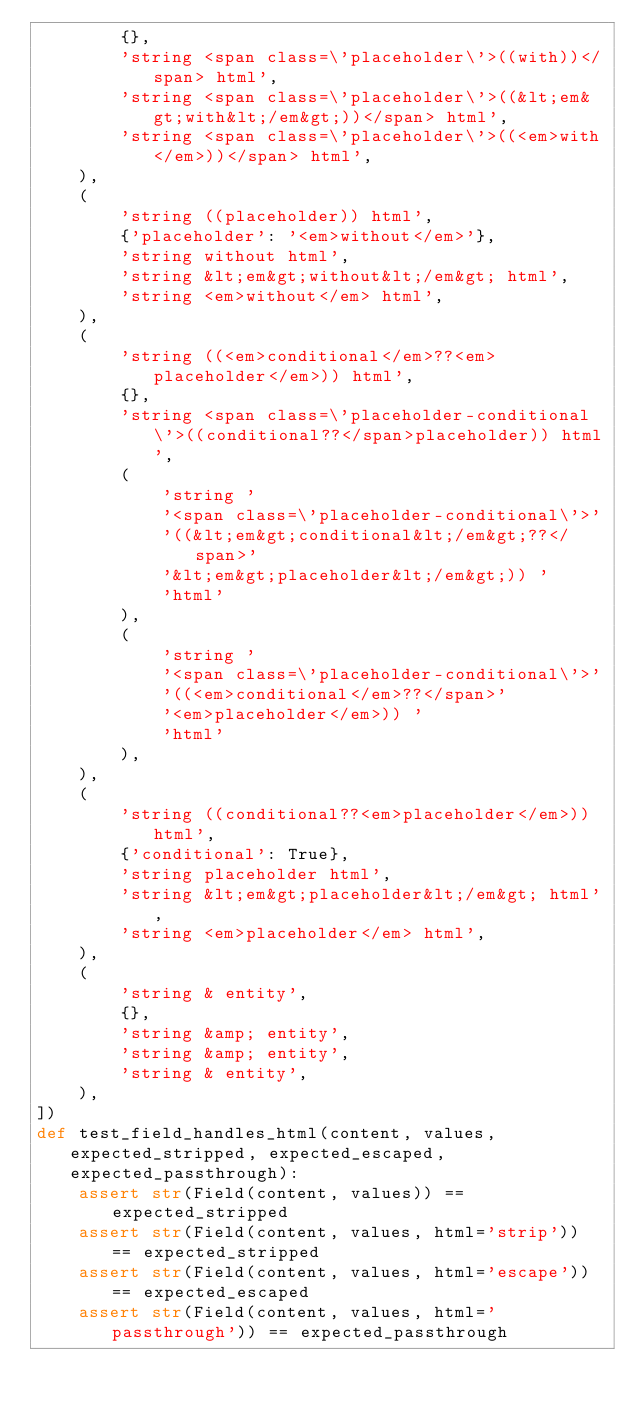Convert code to text. <code><loc_0><loc_0><loc_500><loc_500><_Python_>        {},
        'string <span class=\'placeholder\'>((with))</span> html',
        'string <span class=\'placeholder\'>((&lt;em&gt;with&lt;/em&gt;))</span> html',
        'string <span class=\'placeholder\'>((<em>with</em>))</span> html',
    ),
    (
        'string ((placeholder)) html',
        {'placeholder': '<em>without</em>'},
        'string without html',
        'string &lt;em&gt;without&lt;/em&gt; html',
        'string <em>without</em> html',
    ),
    (
        'string ((<em>conditional</em>??<em>placeholder</em>)) html',
        {},
        'string <span class=\'placeholder-conditional\'>((conditional??</span>placeholder)) html',
        (
            'string '
            '<span class=\'placeholder-conditional\'>'
            '((&lt;em&gt;conditional&lt;/em&gt;??</span>'
            '&lt;em&gt;placeholder&lt;/em&gt;)) '
            'html'
        ),
        (
            'string '
            '<span class=\'placeholder-conditional\'>'
            '((<em>conditional</em>??</span>'
            '<em>placeholder</em>)) '
            'html'
        ),
    ),
    (
        'string ((conditional??<em>placeholder</em>)) html',
        {'conditional': True},
        'string placeholder html',
        'string &lt;em&gt;placeholder&lt;/em&gt; html',
        'string <em>placeholder</em> html',
    ),
    (
        'string & entity',
        {},
        'string &amp; entity',
        'string &amp; entity',
        'string & entity',
    ),
])
def test_field_handles_html(content, values, expected_stripped, expected_escaped, expected_passthrough):
    assert str(Field(content, values)) == expected_stripped
    assert str(Field(content, values, html='strip')) == expected_stripped
    assert str(Field(content, values, html='escape')) == expected_escaped
    assert str(Field(content, values, html='passthrough')) == expected_passthrough
</code> 